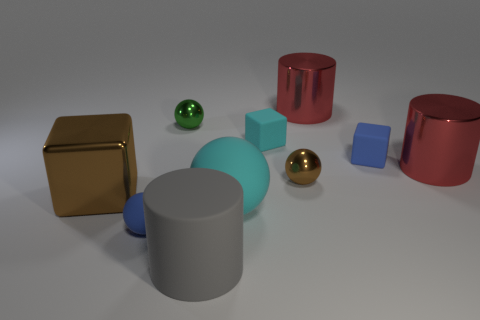What could these objects represent or symbolize, if we were to see them as more than just shapes? The objects could symbolize a variety of concepts. The spheres might represent wholeness and unity, the cubes could signify stability and order, and the cylinders might denote strength and support. The arrangement of differently sized shapes could also speak to diversity and the uniqueness of individuals within a community. 